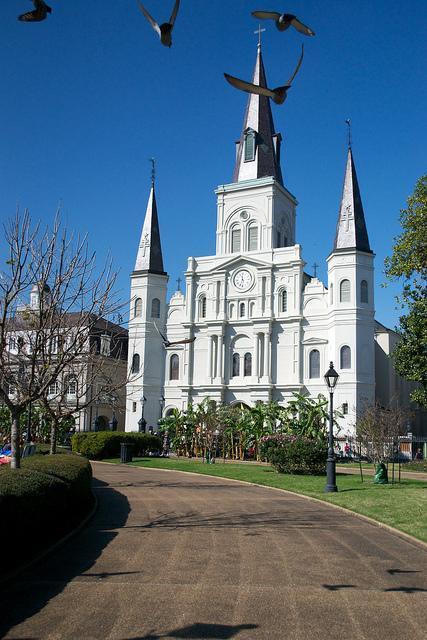How many birds are in the picture?
Give a very brief answer. 4. 